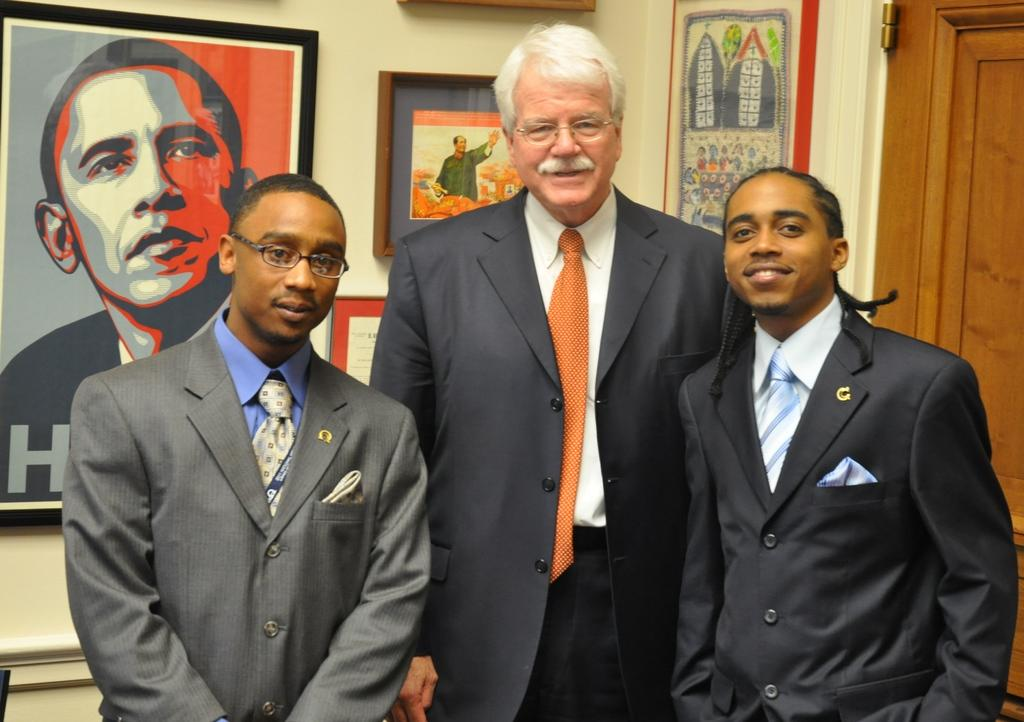What is the main subject of the image? The main subject of the image is a group of people standing. Can you describe any architectural features in the image? Yes, there is a door visible in the image. What else can be seen on the walls in the image? There are photo frames on a wall in the image. What type of trousers are the people wearing in the image? There is no information about the type of trousers the people are wearing in the image. Is there any meat visible in the image? No, there is no meat present in the image. 